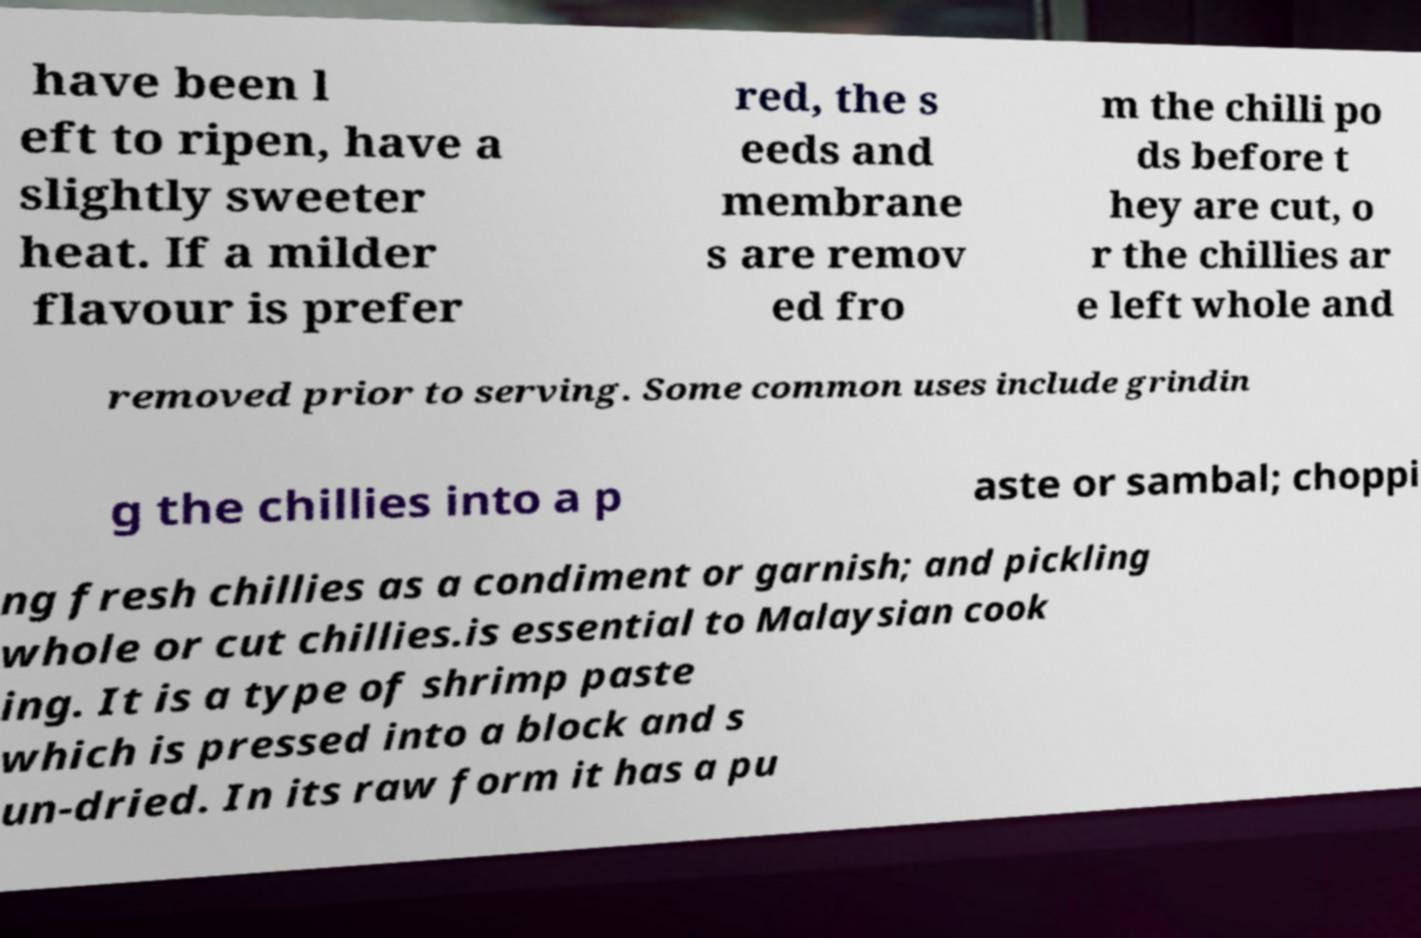Please read and relay the text visible in this image. What does it say? have been l eft to ripen, have a slightly sweeter heat. If a milder flavour is prefer red, the s eeds and membrane s are remov ed fro m the chilli po ds before t hey are cut, o r the chillies ar e left whole and removed prior to serving. Some common uses include grindin g the chillies into a p aste or sambal; choppi ng fresh chillies as a condiment or garnish; and pickling whole or cut chillies.is essential to Malaysian cook ing. It is a type of shrimp paste which is pressed into a block and s un-dried. In its raw form it has a pu 